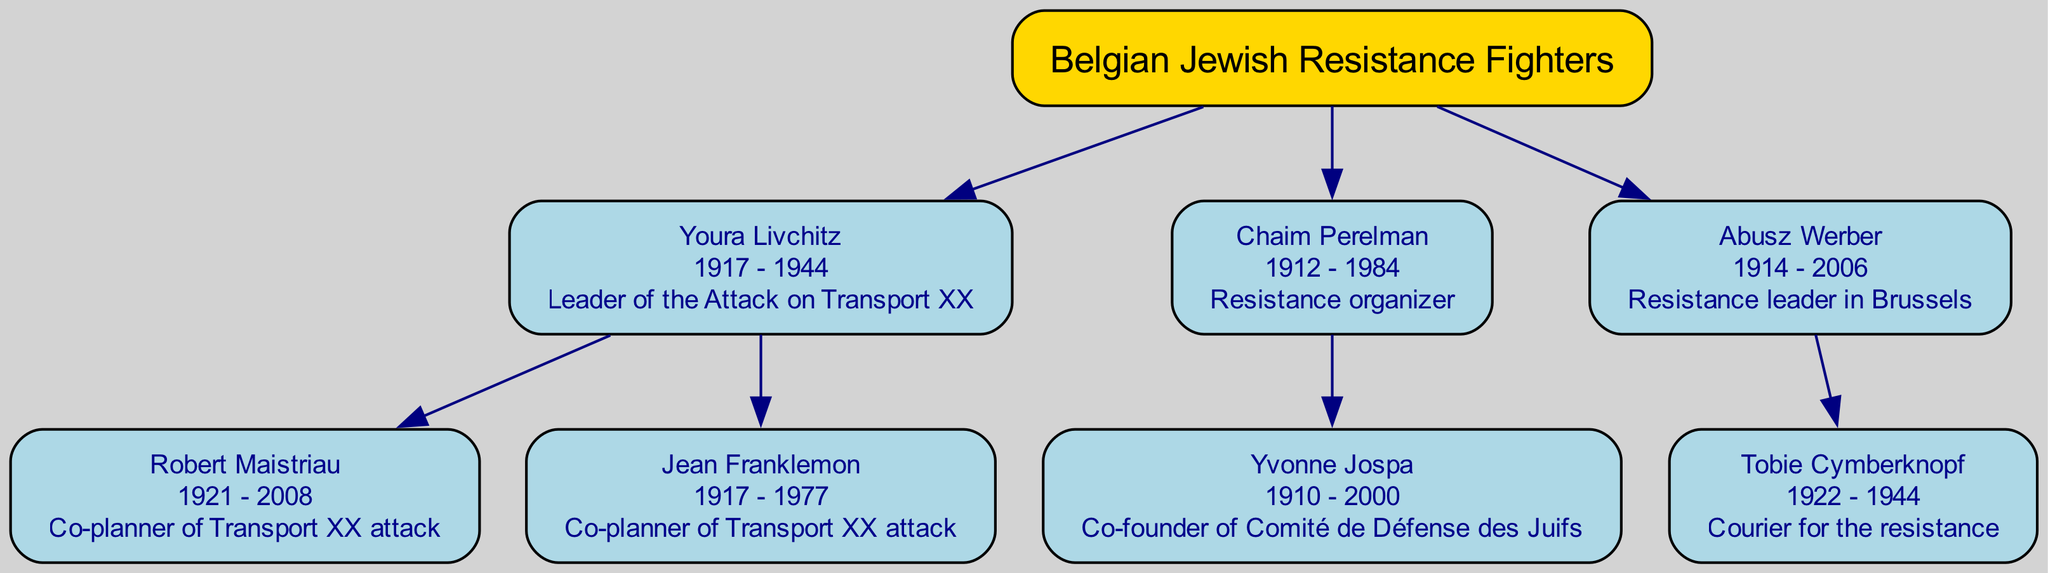What is the birth year of Youra Livchitz? The diagram shows that Youra Livchitz was born in 1917, which is explicitly stated in their node.
Answer: 1917 Who was the leader of the Attack on Transport XX? The diagram clearly labels Youra Livchitz as the leader of the Attack on Transport XX in their role description.
Answer: Youra Livchitz How many children did Chaim Perelman have? The diagram indicates that Chaim Perelman has one child, Yvonne Jospa, as shown by the single child node connected to him.
Answer: 1 What role did Tobie Cymberknopf have during the resistance? The diagram states that Tobie Cymberknopf's role was a courier for the resistance in their corresponding node.
Answer: Courier for the resistance Which individual co-planned the Attack on Transport XX along with Youra Livchitz? The diagram indicates that both Robert Maistriau and Jean Franklemon co-planned the Attack on Transport XX, as they are listed as children of Youra Livchitz.
Answer: Robert Maistriau and Jean Franklemon What is the death year of Abusz Werber? According to the diagram, the death year of Abusz Werber is 2006, as listed in their node.
Answer: 2006 Which node contains the co-founder of Comité de Défense des Juifs? The node for Yvonne Jospa contains the description stating she is the co-founder of Comité de Défense des Juifs, making it clear where this information is found.
Answer: Yvonne Jospa Who was born in 1922? The diagram shows that Tobie Cymberknopf was born in 1922, as mentioned in their node.
Answer: Tobie Cymberknopf How many total resistance fighters are listed in the diagram? The diagram includes a total of five individuals: the three listed as main roles and their respective children. Thus, counting these gives a total of five entities.
Answer: 5 